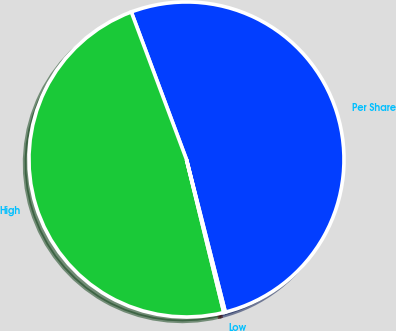<chart> <loc_0><loc_0><loc_500><loc_500><pie_chart><fcel>Per Share<fcel>High<fcel>Low<nl><fcel>51.73%<fcel>48.11%<fcel>0.16%<nl></chart> 